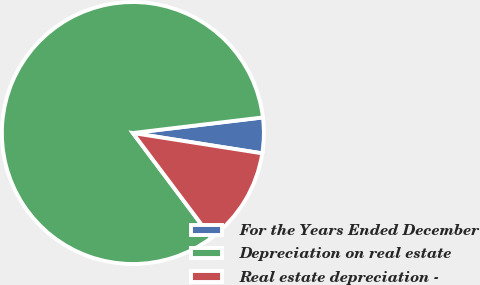Convert chart. <chart><loc_0><loc_0><loc_500><loc_500><pie_chart><fcel>For the Years Ended December<fcel>Depreciation on real estate<fcel>Real estate depreciation -<nl><fcel>4.38%<fcel>83.35%<fcel>12.28%<nl></chart> 